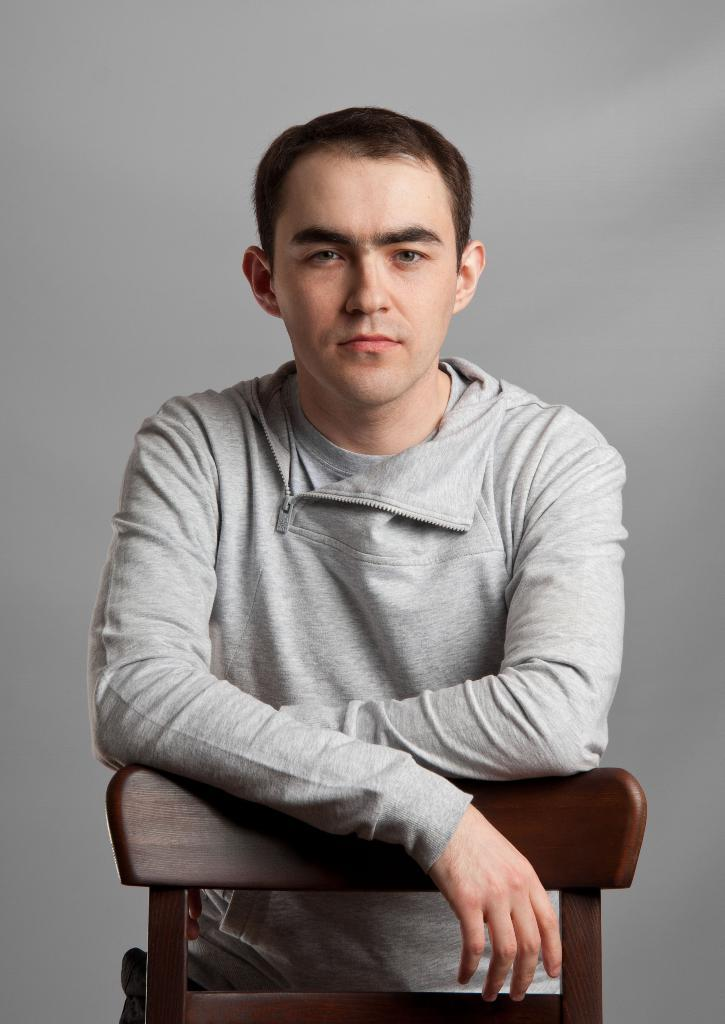What is the main subject of the image? There is a man in the image. What object is present in the image that the man might interact with? There is a chair in the image. Can you describe the background of the image? The background of the image is plain. What type of yak can be seen in the image? There is no yak present in the image. How many babies are visible in the image? There are no babies present in the image. 